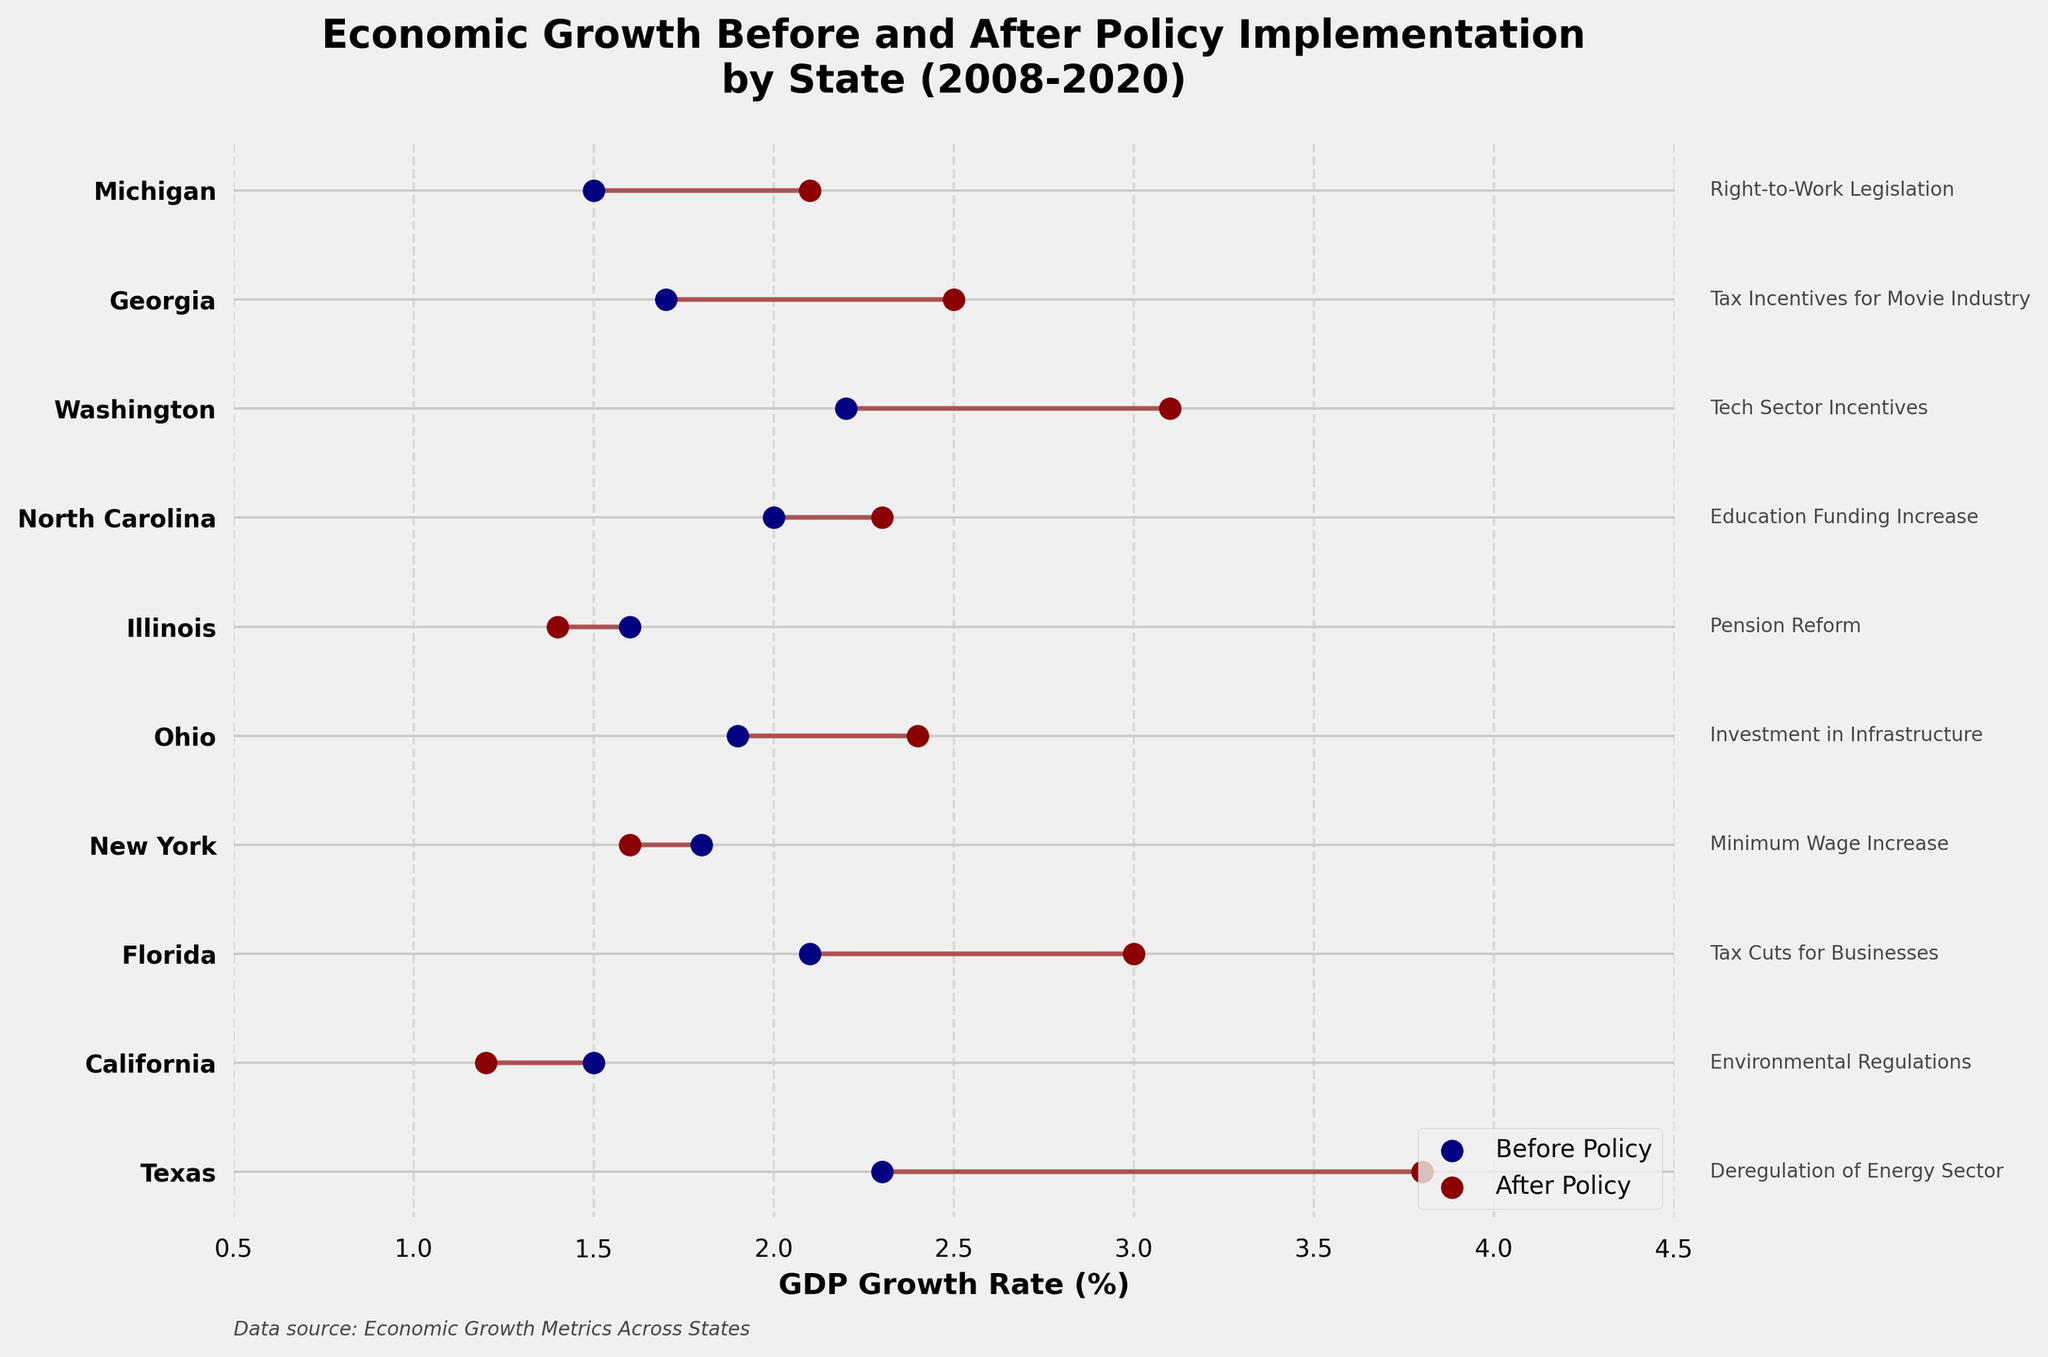What is the title of the plot? The title is usually placed at the top of the plot. In this case, it reads "Economic Growth Before and After Policy Implementation by State (2008-2020)."
Answer: Economic Growth Before and After Policy Implementation by State (2008-2020) Which state has the highest GDP growth rate after policy implementation? The plot shows GDP growth rates on the x-axis with states on the y-axis. The highest "After Policy" GDP growth rate is for Texas, with a rate of 3.8%.
Answer: Texas What is the GDP growth rate of California before and after policy implementation? Look at the plot where California is labeled on the y-axis. The blue dot represents the "Before Policy" rate and the red dot represents the "After Policy" rate. The values are 1.5% (before) and 1.2% (after).
Answer: 1.5% (before), 1.2% (after) Which state showed the smallest change in GDP growth rate after policy implementation? The smallest change in GDP growth rate can be observed by finding the shortest horizontal line between the "Before" and "After" dots. Illinois shows the smallest change, with rates of 1.6% before and 1.4% after, resulting in a 0.2% decrease.
Answer: Illinois What was the GDP growth rate before policy implementation for states with education-related policies? Find the states labeled with education-related policies in the text. North Carolina has the "Education Funding Increase" policy. The "Before Policy" GDP growth rate for North Carolina is 2%.
Answer: 2% Which state had a decrease in GDP growth rate after the policy was implemented? Identify states where the "After Policy" dot is to the left of the "Before Policy" dot. California, New York, and Illinois show decreases in their GDP growth rates after policy implementation.
Answer: California, New York, Illinois Compare the GDP growth rate improvement of Texas and Florida after policy implementations. Which state had a larger increase? Calculate the change for each state by subtracting the "Before" rate from the "After" rate. Texas: 3.8% - 2.3% = 1.5%, Florida: 3.0% - 2.1% = 0.9%. Texas had a larger increase.
Answer: Texas What is the average GDP growth rate before the policy implementations for all states? Sum all the "Before Policy" GDP growth rates and divide by the number of states (10). The sum is 20.6%, so the average is 20.6% / 10 = 2.06%.
Answer: 2.06% Which state implemented environmental regulations, and what effect did it have on GDP growth? Locate the state associated with the "Environmental Regulations" policy text. California implemented such regulations, and the GDP growth rate decreased from 1.5% to 1.2%.
Answer: California; Decrease What is the range of GDP growth rates after policy implementation across all states? Identify the minimum and maximum "After Policy" GDP growth rates. The lowest is California at 1.2%, and the highest is Texas at 3.8%. The range is 3.8% - 1.2% = 2.6%.
Answer: 2.6% 